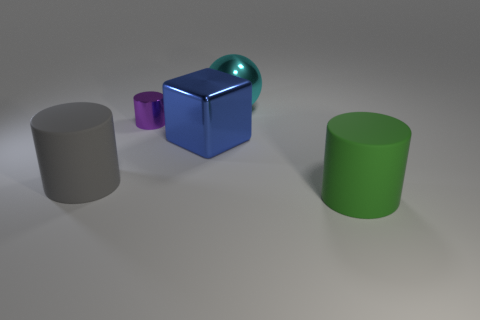Add 3 green matte things. How many objects exist? 8 Subtract all cylinders. How many objects are left? 2 Add 1 small yellow rubber blocks. How many small yellow rubber blocks exist? 1 Subtract 0 gray balls. How many objects are left? 5 Subtract all large purple cylinders. Subtract all blue shiny cubes. How many objects are left? 4 Add 4 large gray matte cylinders. How many large gray matte cylinders are left? 5 